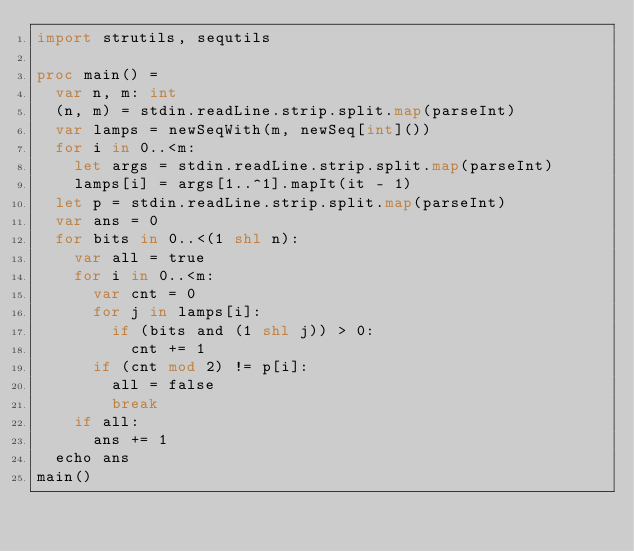<code> <loc_0><loc_0><loc_500><loc_500><_Nim_>import strutils, sequtils

proc main() =
  var n, m: int
  (n, m) = stdin.readLine.strip.split.map(parseInt)
  var lamps = newSeqWith(m, newSeq[int]())
  for i in 0..<m:
    let args = stdin.readLine.strip.split.map(parseInt)
    lamps[i] = args[1..^1].mapIt(it - 1)
  let p = stdin.readLine.strip.split.map(parseInt)
  var ans = 0
  for bits in 0..<(1 shl n):
    var all = true
    for i in 0..<m:
      var cnt = 0
      for j in lamps[i]:
        if (bits and (1 shl j)) > 0:
          cnt += 1
      if (cnt mod 2) != p[i]:
        all = false
        break
    if all:
      ans += 1
  echo ans
main()
</code> 